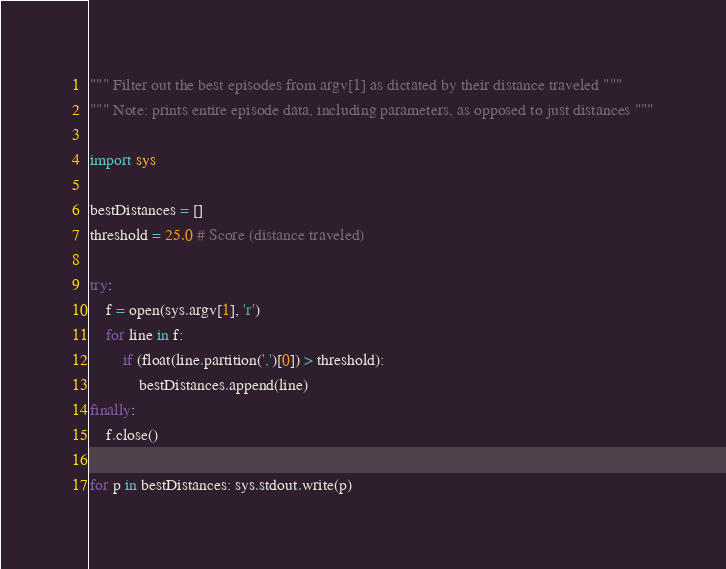Convert code to text. <code><loc_0><loc_0><loc_500><loc_500><_Python_>""" Filter out the best episodes from argv[1] as dictated by their distance traveled """
""" Note: prints entire episode data, including parameters, as opposed to just distances """

import sys

bestDistances = []
threshold = 25.0 # Score (distance traveled)

try:
    f = open(sys.argv[1], 'r')
    for line in f: 
        if (float(line.partition(',')[0]) > threshold):
            bestDistances.append(line)
finally:
    f.close()

for p in bestDistances: sys.stdout.write(p)

</code> 